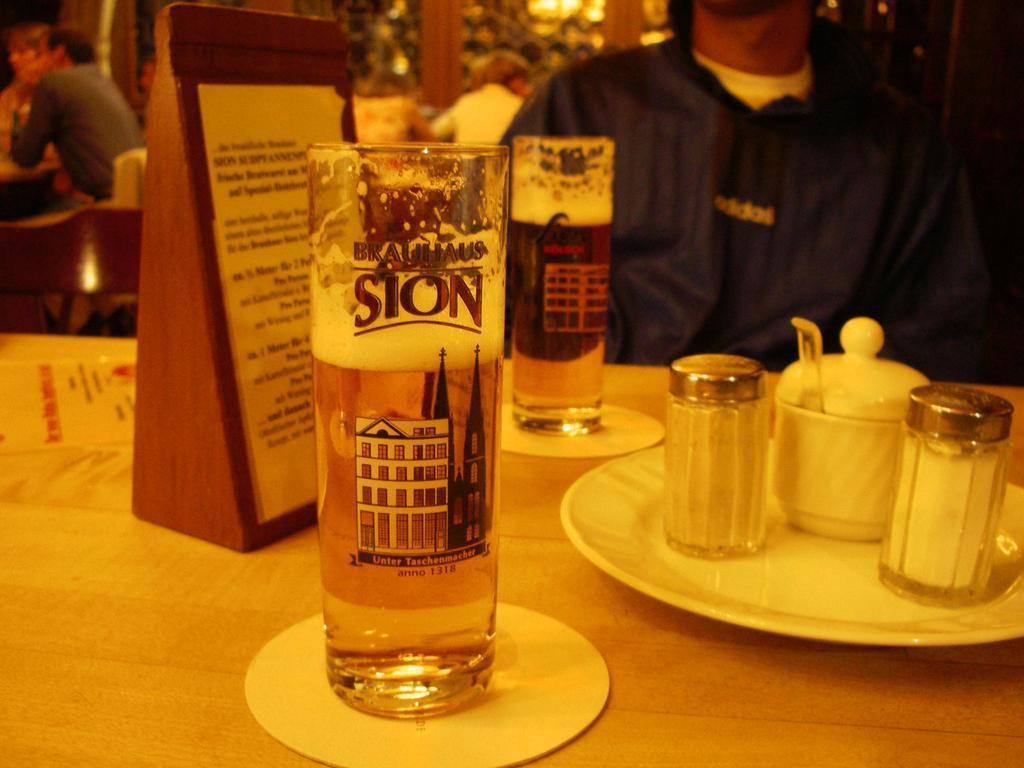<image>
Summarize the visual content of the image. A glass with a picture of a building on it is also labeled with the year 1318. 